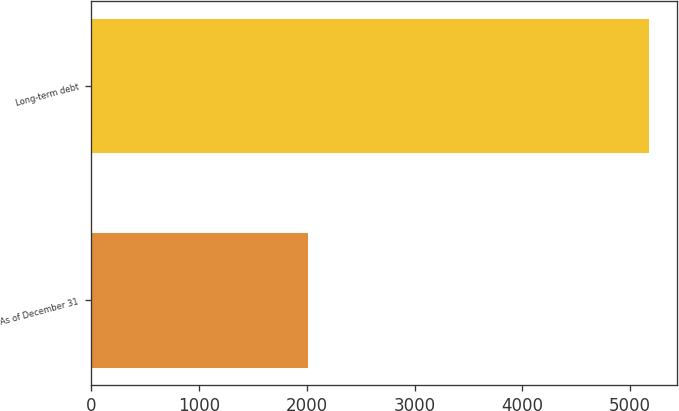<chart> <loc_0><loc_0><loc_500><loc_500><bar_chart><fcel>As of December 31<fcel>Long-term debt<nl><fcel>2015<fcel>5175<nl></chart> 